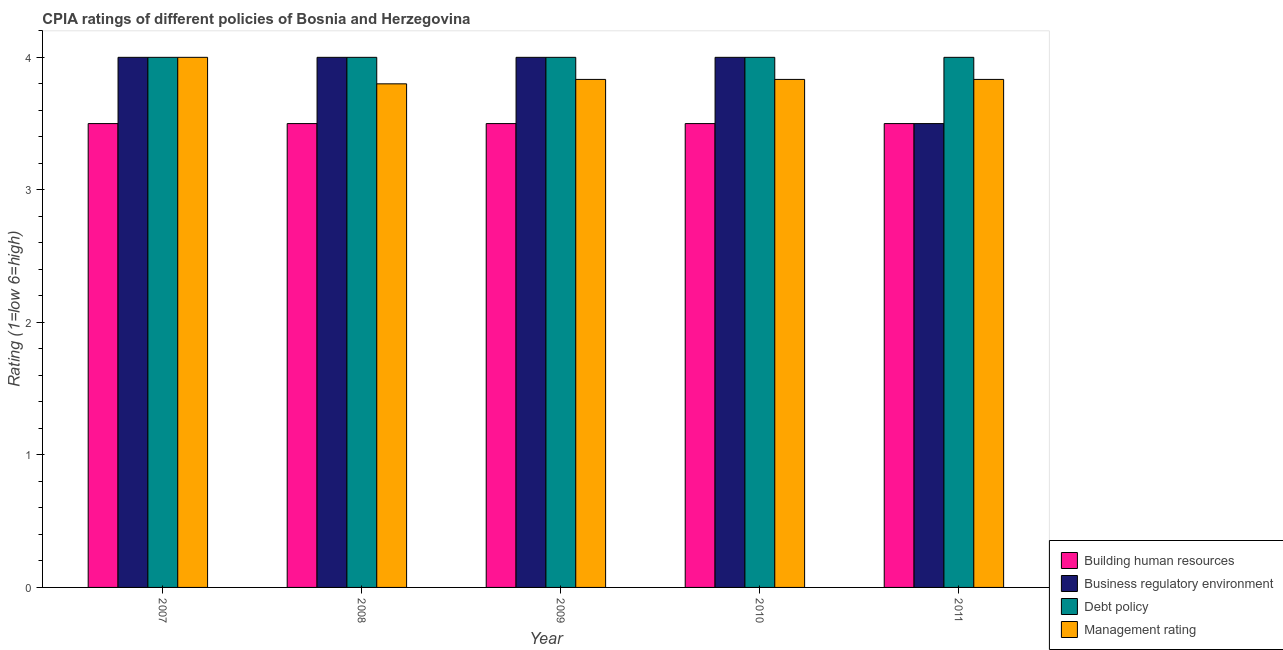Are the number of bars per tick equal to the number of legend labels?
Give a very brief answer. Yes. How many bars are there on the 1st tick from the left?
Make the answer very short. 4. How many bars are there on the 1st tick from the right?
Your answer should be compact. 4. What is the label of the 2nd group of bars from the left?
Make the answer very short. 2008. In how many cases, is the number of bars for a given year not equal to the number of legend labels?
Make the answer very short. 0. What is the cpia rating of debt policy in 2010?
Your response must be concise. 4. Across all years, what is the minimum cpia rating of management?
Keep it short and to the point. 3.8. In which year was the cpia rating of debt policy maximum?
Your response must be concise. 2007. What is the total cpia rating of building human resources in the graph?
Make the answer very short. 17.5. What is the difference between the cpia rating of management in 2010 and the cpia rating of building human resources in 2007?
Keep it short and to the point. -0.17. What is the average cpia rating of debt policy per year?
Your response must be concise. 4. In how many years, is the cpia rating of management greater than 2?
Provide a short and direct response. 5. Is the cpia rating of business regulatory environment in 2007 less than that in 2011?
Make the answer very short. No. Is the difference between the cpia rating of business regulatory environment in 2009 and 2011 greater than the difference between the cpia rating of debt policy in 2009 and 2011?
Provide a short and direct response. No. What is the difference between the highest and the second highest cpia rating of business regulatory environment?
Provide a succinct answer. 0. What is the difference between the highest and the lowest cpia rating of business regulatory environment?
Offer a terse response. 0.5. What does the 1st bar from the left in 2008 represents?
Your answer should be very brief. Building human resources. What does the 2nd bar from the right in 2007 represents?
Give a very brief answer. Debt policy. Is it the case that in every year, the sum of the cpia rating of building human resources and cpia rating of business regulatory environment is greater than the cpia rating of debt policy?
Provide a succinct answer. Yes. How many bars are there?
Make the answer very short. 20. Are all the bars in the graph horizontal?
Your answer should be compact. No. How many years are there in the graph?
Make the answer very short. 5. Does the graph contain any zero values?
Your response must be concise. No. Does the graph contain grids?
Offer a terse response. No. Where does the legend appear in the graph?
Provide a short and direct response. Bottom right. How are the legend labels stacked?
Your answer should be very brief. Vertical. What is the title of the graph?
Give a very brief answer. CPIA ratings of different policies of Bosnia and Herzegovina. Does "Tertiary schools" appear as one of the legend labels in the graph?
Your answer should be compact. No. What is the label or title of the X-axis?
Keep it short and to the point. Year. What is the Rating (1=low 6=high) in Building human resources in 2007?
Your response must be concise. 3.5. What is the Rating (1=low 6=high) in Management rating in 2007?
Keep it short and to the point. 4. What is the Rating (1=low 6=high) in Business regulatory environment in 2008?
Provide a succinct answer. 4. What is the Rating (1=low 6=high) of Management rating in 2008?
Your answer should be very brief. 3.8. What is the Rating (1=low 6=high) of Management rating in 2009?
Offer a very short reply. 3.83. What is the Rating (1=low 6=high) in Building human resources in 2010?
Give a very brief answer. 3.5. What is the Rating (1=low 6=high) of Business regulatory environment in 2010?
Provide a short and direct response. 4. What is the Rating (1=low 6=high) in Debt policy in 2010?
Your answer should be very brief. 4. What is the Rating (1=low 6=high) of Management rating in 2010?
Your answer should be compact. 3.83. What is the Rating (1=low 6=high) in Building human resources in 2011?
Make the answer very short. 3.5. What is the Rating (1=low 6=high) in Business regulatory environment in 2011?
Provide a short and direct response. 3.5. What is the Rating (1=low 6=high) of Debt policy in 2011?
Your answer should be very brief. 4. What is the Rating (1=low 6=high) of Management rating in 2011?
Make the answer very short. 3.83. Across all years, what is the maximum Rating (1=low 6=high) in Building human resources?
Provide a succinct answer. 3.5. Across all years, what is the minimum Rating (1=low 6=high) of Building human resources?
Ensure brevity in your answer.  3.5. Across all years, what is the minimum Rating (1=low 6=high) of Business regulatory environment?
Provide a short and direct response. 3.5. What is the total Rating (1=low 6=high) in Building human resources in the graph?
Your answer should be compact. 17.5. What is the total Rating (1=low 6=high) of Business regulatory environment in the graph?
Your answer should be compact. 19.5. What is the total Rating (1=low 6=high) in Debt policy in the graph?
Your answer should be compact. 20. What is the total Rating (1=low 6=high) of Management rating in the graph?
Offer a terse response. 19.3. What is the difference between the Rating (1=low 6=high) in Management rating in 2007 and that in 2008?
Make the answer very short. 0.2. What is the difference between the Rating (1=low 6=high) of Building human resources in 2007 and that in 2009?
Your answer should be compact. 0. What is the difference between the Rating (1=low 6=high) in Business regulatory environment in 2007 and that in 2009?
Offer a very short reply. 0. What is the difference between the Rating (1=low 6=high) of Debt policy in 2007 and that in 2009?
Give a very brief answer. 0. What is the difference between the Rating (1=low 6=high) in Business regulatory environment in 2007 and that in 2010?
Provide a succinct answer. 0. What is the difference between the Rating (1=low 6=high) in Debt policy in 2007 and that in 2010?
Your answer should be very brief. 0. What is the difference between the Rating (1=low 6=high) of Management rating in 2007 and that in 2010?
Make the answer very short. 0.17. What is the difference between the Rating (1=low 6=high) of Building human resources in 2007 and that in 2011?
Offer a very short reply. 0. What is the difference between the Rating (1=low 6=high) in Debt policy in 2007 and that in 2011?
Offer a very short reply. 0. What is the difference between the Rating (1=low 6=high) of Management rating in 2008 and that in 2009?
Ensure brevity in your answer.  -0.03. What is the difference between the Rating (1=low 6=high) in Management rating in 2008 and that in 2010?
Your response must be concise. -0.03. What is the difference between the Rating (1=low 6=high) in Business regulatory environment in 2008 and that in 2011?
Your answer should be very brief. 0.5. What is the difference between the Rating (1=low 6=high) of Management rating in 2008 and that in 2011?
Offer a very short reply. -0.03. What is the difference between the Rating (1=low 6=high) in Building human resources in 2009 and that in 2010?
Your response must be concise. 0. What is the difference between the Rating (1=low 6=high) of Debt policy in 2009 and that in 2010?
Offer a terse response. 0. What is the difference between the Rating (1=low 6=high) of Management rating in 2009 and that in 2010?
Your answer should be compact. 0. What is the difference between the Rating (1=low 6=high) of Business regulatory environment in 2009 and that in 2011?
Your answer should be very brief. 0.5. What is the difference between the Rating (1=low 6=high) in Management rating in 2009 and that in 2011?
Ensure brevity in your answer.  0. What is the difference between the Rating (1=low 6=high) of Building human resources in 2007 and the Rating (1=low 6=high) of Business regulatory environment in 2008?
Make the answer very short. -0.5. What is the difference between the Rating (1=low 6=high) of Building human resources in 2007 and the Rating (1=low 6=high) of Debt policy in 2008?
Your response must be concise. -0.5. What is the difference between the Rating (1=low 6=high) of Building human resources in 2007 and the Rating (1=low 6=high) of Management rating in 2008?
Your answer should be very brief. -0.3. What is the difference between the Rating (1=low 6=high) of Business regulatory environment in 2007 and the Rating (1=low 6=high) of Debt policy in 2009?
Your answer should be very brief. 0. What is the difference between the Rating (1=low 6=high) in Building human resources in 2007 and the Rating (1=low 6=high) in Management rating in 2010?
Make the answer very short. -0.33. What is the difference between the Rating (1=low 6=high) of Debt policy in 2007 and the Rating (1=low 6=high) of Management rating in 2010?
Provide a succinct answer. 0.17. What is the difference between the Rating (1=low 6=high) in Building human resources in 2007 and the Rating (1=low 6=high) in Business regulatory environment in 2011?
Make the answer very short. 0. What is the difference between the Rating (1=low 6=high) of Building human resources in 2007 and the Rating (1=low 6=high) of Debt policy in 2011?
Provide a succinct answer. -0.5. What is the difference between the Rating (1=low 6=high) in Debt policy in 2007 and the Rating (1=low 6=high) in Management rating in 2011?
Provide a short and direct response. 0.17. What is the difference between the Rating (1=low 6=high) in Building human resources in 2008 and the Rating (1=low 6=high) in Debt policy in 2009?
Offer a terse response. -0.5. What is the difference between the Rating (1=low 6=high) in Business regulatory environment in 2008 and the Rating (1=low 6=high) in Management rating in 2009?
Offer a very short reply. 0.17. What is the difference between the Rating (1=low 6=high) in Building human resources in 2008 and the Rating (1=low 6=high) in Business regulatory environment in 2010?
Offer a very short reply. -0.5. What is the difference between the Rating (1=low 6=high) in Business regulatory environment in 2008 and the Rating (1=low 6=high) in Management rating in 2010?
Provide a succinct answer. 0.17. What is the difference between the Rating (1=low 6=high) in Building human resources in 2008 and the Rating (1=low 6=high) in Debt policy in 2011?
Make the answer very short. -0.5. What is the difference between the Rating (1=low 6=high) in Business regulatory environment in 2008 and the Rating (1=low 6=high) in Debt policy in 2011?
Provide a short and direct response. 0. What is the difference between the Rating (1=low 6=high) in Debt policy in 2008 and the Rating (1=low 6=high) in Management rating in 2011?
Offer a very short reply. 0.17. What is the difference between the Rating (1=low 6=high) of Building human resources in 2009 and the Rating (1=low 6=high) of Business regulatory environment in 2010?
Ensure brevity in your answer.  -0.5. What is the difference between the Rating (1=low 6=high) in Building human resources in 2009 and the Rating (1=low 6=high) in Management rating in 2010?
Offer a very short reply. -0.33. What is the difference between the Rating (1=low 6=high) of Business regulatory environment in 2009 and the Rating (1=low 6=high) of Debt policy in 2010?
Make the answer very short. 0. What is the difference between the Rating (1=low 6=high) of Building human resources in 2009 and the Rating (1=low 6=high) of Management rating in 2011?
Provide a short and direct response. -0.33. What is the difference between the Rating (1=low 6=high) in Business regulatory environment in 2009 and the Rating (1=low 6=high) in Debt policy in 2011?
Your answer should be very brief. 0. What is the difference between the Rating (1=low 6=high) in Business regulatory environment in 2009 and the Rating (1=low 6=high) in Management rating in 2011?
Your answer should be very brief. 0.17. What is the difference between the Rating (1=low 6=high) in Building human resources in 2010 and the Rating (1=low 6=high) in Business regulatory environment in 2011?
Ensure brevity in your answer.  0. What is the difference between the Rating (1=low 6=high) of Building human resources in 2010 and the Rating (1=low 6=high) of Debt policy in 2011?
Offer a very short reply. -0.5. What is the average Rating (1=low 6=high) in Debt policy per year?
Your response must be concise. 4. What is the average Rating (1=low 6=high) of Management rating per year?
Make the answer very short. 3.86. In the year 2007, what is the difference between the Rating (1=low 6=high) of Building human resources and Rating (1=low 6=high) of Debt policy?
Offer a terse response. -0.5. In the year 2007, what is the difference between the Rating (1=low 6=high) of Building human resources and Rating (1=low 6=high) of Management rating?
Make the answer very short. -0.5. In the year 2008, what is the difference between the Rating (1=low 6=high) of Building human resources and Rating (1=low 6=high) of Business regulatory environment?
Make the answer very short. -0.5. In the year 2008, what is the difference between the Rating (1=low 6=high) of Building human resources and Rating (1=low 6=high) of Debt policy?
Make the answer very short. -0.5. In the year 2008, what is the difference between the Rating (1=low 6=high) of Business regulatory environment and Rating (1=low 6=high) of Management rating?
Ensure brevity in your answer.  0.2. In the year 2008, what is the difference between the Rating (1=low 6=high) in Debt policy and Rating (1=low 6=high) in Management rating?
Make the answer very short. 0.2. In the year 2009, what is the difference between the Rating (1=low 6=high) in Building human resources and Rating (1=low 6=high) in Management rating?
Provide a short and direct response. -0.33. In the year 2009, what is the difference between the Rating (1=low 6=high) of Business regulatory environment and Rating (1=low 6=high) of Debt policy?
Make the answer very short. 0. In the year 2009, what is the difference between the Rating (1=low 6=high) of Business regulatory environment and Rating (1=low 6=high) of Management rating?
Provide a short and direct response. 0.17. In the year 2009, what is the difference between the Rating (1=low 6=high) of Debt policy and Rating (1=low 6=high) of Management rating?
Offer a terse response. 0.17. In the year 2010, what is the difference between the Rating (1=low 6=high) in Building human resources and Rating (1=low 6=high) in Debt policy?
Offer a terse response. -0.5. In the year 2010, what is the difference between the Rating (1=low 6=high) of Business regulatory environment and Rating (1=low 6=high) of Management rating?
Ensure brevity in your answer.  0.17. In the year 2011, what is the difference between the Rating (1=low 6=high) in Building human resources and Rating (1=low 6=high) in Business regulatory environment?
Make the answer very short. 0. In the year 2011, what is the difference between the Rating (1=low 6=high) in Building human resources and Rating (1=low 6=high) in Debt policy?
Your response must be concise. -0.5. In the year 2011, what is the difference between the Rating (1=low 6=high) in Business regulatory environment and Rating (1=low 6=high) in Debt policy?
Your answer should be compact. -0.5. In the year 2011, what is the difference between the Rating (1=low 6=high) of Business regulatory environment and Rating (1=low 6=high) of Management rating?
Your answer should be compact. -0.33. In the year 2011, what is the difference between the Rating (1=low 6=high) of Debt policy and Rating (1=low 6=high) of Management rating?
Your answer should be compact. 0.17. What is the ratio of the Rating (1=low 6=high) in Debt policy in 2007 to that in 2008?
Give a very brief answer. 1. What is the ratio of the Rating (1=low 6=high) of Management rating in 2007 to that in 2008?
Your response must be concise. 1.05. What is the ratio of the Rating (1=low 6=high) in Building human resources in 2007 to that in 2009?
Your response must be concise. 1. What is the ratio of the Rating (1=low 6=high) in Debt policy in 2007 to that in 2009?
Offer a terse response. 1. What is the ratio of the Rating (1=low 6=high) of Management rating in 2007 to that in 2009?
Make the answer very short. 1.04. What is the ratio of the Rating (1=low 6=high) in Building human resources in 2007 to that in 2010?
Give a very brief answer. 1. What is the ratio of the Rating (1=low 6=high) in Debt policy in 2007 to that in 2010?
Ensure brevity in your answer.  1. What is the ratio of the Rating (1=low 6=high) of Management rating in 2007 to that in 2010?
Your answer should be compact. 1.04. What is the ratio of the Rating (1=low 6=high) in Building human resources in 2007 to that in 2011?
Provide a succinct answer. 1. What is the ratio of the Rating (1=low 6=high) of Debt policy in 2007 to that in 2011?
Provide a succinct answer. 1. What is the ratio of the Rating (1=low 6=high) of Management rating in 2007 to that in 2011?
Make the answer very short. 1.04. What is the ratio of the Rating (1=low 6=high) in Building human resources in 2008 to that in 2009?
Ensure brevity in your answer.  1. What is the ratio of the Rating (1=low 6=high) of Business regulatory environment in 2008 to that in 2009?
Make the answer very short. 1. What is the ratio of the Rating (1=low 6=high) of Debt policy in 2008 to that in 2009?
Provide a short and direct response. 1. What is the ratio of the Rating (1=low 6=high) of Management rating in 2008 to that in 2009?
Your answer should be compact. 0.99. What is the ratio of the Rating (1=low 6=high) of Business regulatory environment in 2008 to that in 2010?
Keep it short and to the point. 1. What is the ratio of the Rating (1=low 6=high) of Debt policy in 2008 to that in 2010?
Your answer should be very brief. 1. What is the ratio of the Rating (1=low 6=high) of Management rating in 2008 to that in 2010?
Provide a short and direct response. 0.99. What is the ratio of the Rating (1=low 6=high) in Business regulatory environment in 2008 to that in 2011?
Your answer should be very brief. 1.14. What is the ratio of the Rating (1=low 6=high) in Business regulatory environment in 2009 to that in 2010?
Your answer should be compact. 1. What is the ratio of the Rating (1=low 6=high) in Debt policy in 2009 to that in 2010?
Offer a terse response. 1. What is the ratio of the Rating (1=low 6=high) of Management rating in 2009 to that in 2011?
Offer a terse response. 1. What is the ratio of the Rating (1=low 6=high) of Building human resources in 2010 to that in 2011?
Offer a very short reply. 1. What is the ratio of the Rating (1=low 6=high) in Debt policy in 2010 to that in 2011?
Your answer should be compact. 1. What is the difference between the highest and the second highest Rating (1=low 6=high) of Building human resources?
Keep it short and to the point. 0. What is the difference between the highest and the second highest Rating (1=low 6=high) of Debt policy?
Keep it short and to the point. 0. What is the difference between the highest and the lowest Rating (1=low 6=high) of Building human resources?
Your answer should be very brief. 0. What is the difference between the highest and the lowest Rating (1=low 6=high) of Business regulatory environment?
Your answer should be compact. 0.5. What is the difference between the highest and the lowest Rating (1=low 6=high) in Debt policy?
Offer a very short reply. 0. 